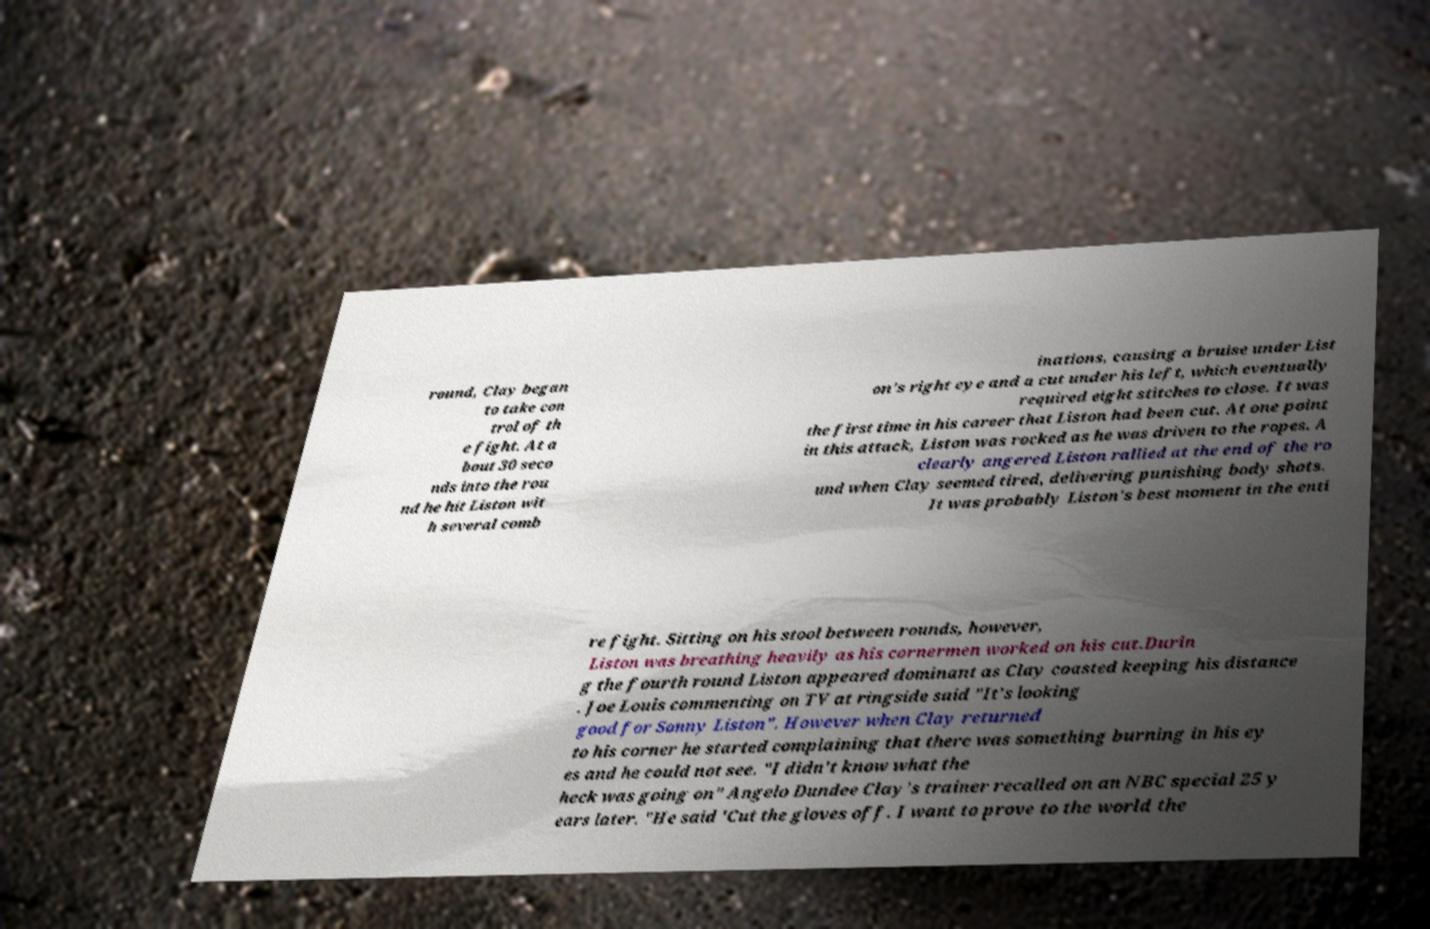Could you extract and type out the text from this image? round, Clay began to take con trol of th e fight. At a bout 30 seco nds into the rou nd he hit Liston wit h several comb inations, causing a bruise under List on's right eye and a cut under his left, which eventually required eight stitches to close. It was the first time in his career that Liston had been cut. At one point in this attack, Liston was rocked as he was driven to the ropes. A clearly angered Liston rallied at the end of the ro und when Clay seemed tired, delivering punishing body shots. It was probably Liston's best moment in the enti re fight. Sitting on his stool between rounds, however, Liston was breathing heavily as his cornermen worked on his cut.Durin g the fourth round Liston appeared dominant as Clay coasted keeping his distance . Joe Louis commenting on TV at ringside said "It's looking good for Sonny Liston". However when Clay returned to his corner he started complaining that there was something burning in his ey es and he could not see. "I didn't know what the heck was going on" Angelo Dundee Clay's trainer recalled on an NBC special 25 y ears later. "He said 'Cut the gloves off. I want to prove to the world the 